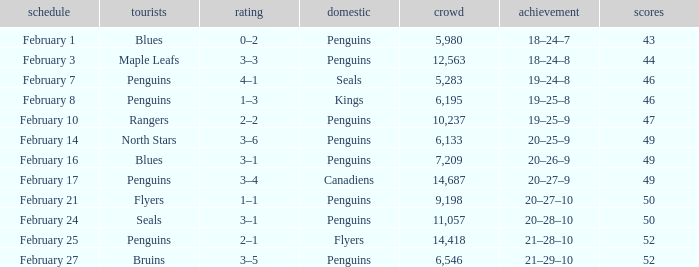Home of kings had what score? 1–3. 